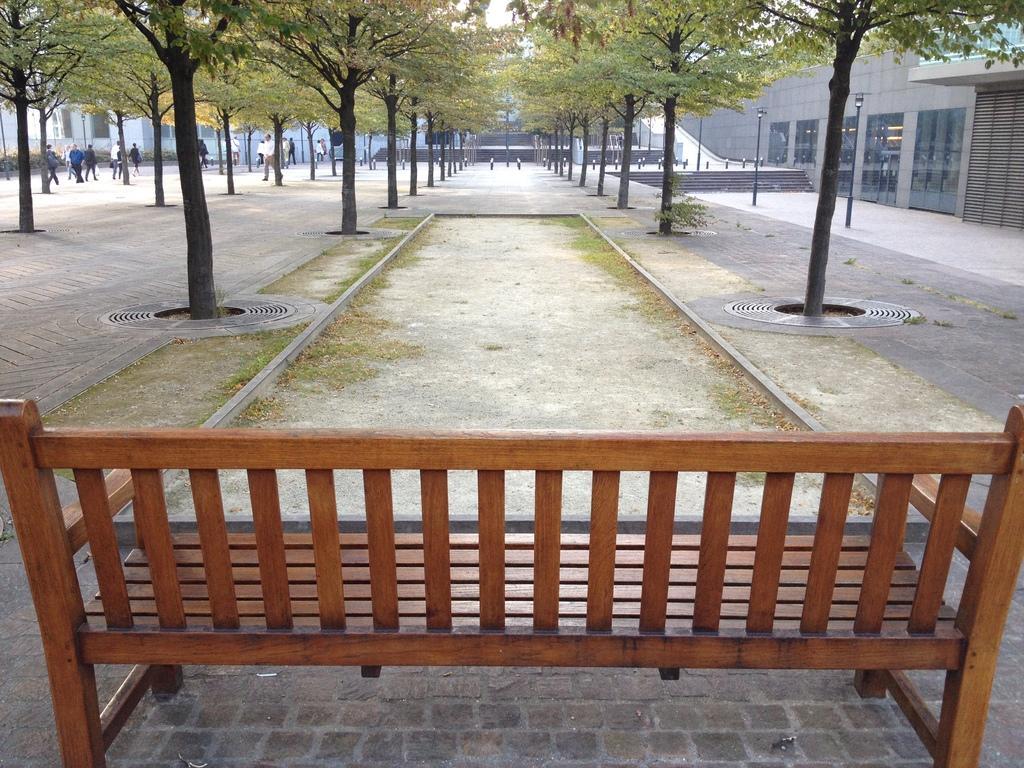In one or two sentences, can you explain what this image depicts? This is an outside view. At the bottom there is a bench. On the right and left side of the image there are two roads. Beside the roads there are many things. On the left side there are few people walking on the road. In the background there are some buildings. 